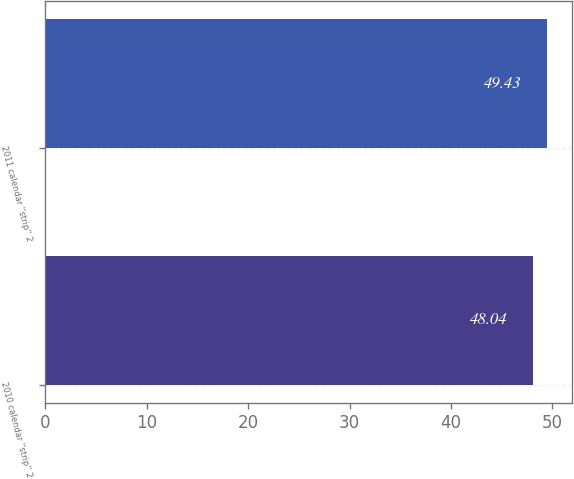<chart> <loc_0><loc_0><loc_500><loc_500><bar_chart><fcel>2010 calendar ''strip'' 2<fcel>2011 calendar ''strip'' 2<nl><fcel>48.04<fcel>49.43<nl></chart> 